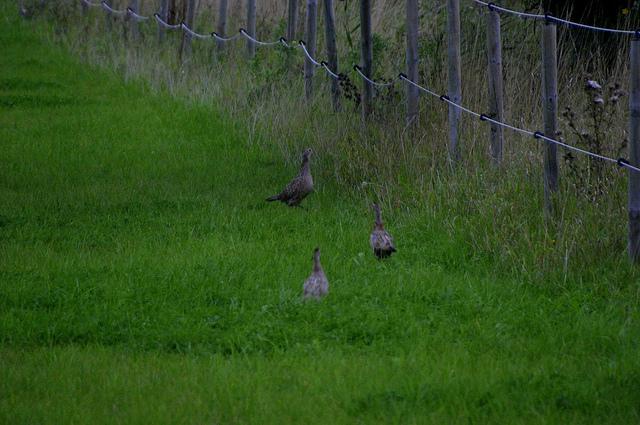Is a fairly steep incline indicated in this photo?
Concise answer only. No. How many animals are in the yard?
Answer briefly. 3. What time of year is it?
Quick response, please. Spring. How many legs does the animal have?
Short answer required. 2. How many poles do you see for the fence?
Concise answer only. 14. What animals are these?
Give a very brief answer. Birds. Are these birds tagged?
Give a very brief answer. No. What kind of animal is standing up?
Give a very brief answer. Bird. How many animals are laying down?
Write a very short answer. 1. Does it look like the scene was shot in winter or summer?
Short answer required. Summer. What colors are the birds?
Short answer required. Gray. Where are the birds?
Quick response, please. In grass. How many animals do you see?
Be succinct. 3. What is covering the ground?
Write a very short answer. Grass. What kind of fence is this?
Quick response, please. Electric. How many brown ducks can you see?
Give a very brief answer. 3. Is the grass patchy?
Quick response, please. No. How many birds are there?
Give a very brief answer. 3. How many birds is there?
Answer briefly. 3. Is this is in the wild?
Quick response, please. No. What color is the fence?
Short answer required. Brown. What kind of animal is this?
Be succinct. Bird. What kind of animals is standing in the grass?
Quick response, please. Ducks. What are the birds doing?
Answer briefly. Walking. What kind of bird is this?
Be succinct. Pigeon. What color is the bird?
Concise answer only. Gray. How many birds?
Keep it brief. 3. Are the birds wild?
Keep it brief. Yes. Is this a friendly park area?
Concise answer only. Yes. Is there snow on the ground?
Be succinct. No. What kind of bird are these?
Write a very short answer. Pigeons. What is the bird standing in front of?
Write a very short answer. Fence. What type of animal is this?
Answer briefly. Bird. Does the grass change color in fall?
Keep it brief. Yes. What type of birds are these?
Write a very short answer. Pigeons. Which animal is this?
Quick response, please. Bird. Are the animals walking around?
Quick response, please. Yes. What type of birds are in this photo?
Write a very short answer. Geese. Is the bird scared of the animal in the foreground?
Short answer required. No. Is this bird in trouble?
Quick response, please. No. Where is barbed wire?
Quick response, please. Fence. How many geese are there?
Give a very brief answer. 3. Are the animals on the same side of the fence?
Keep it brief. Yes. Is the bird looking for food?
Give a very brief answer. Yes. Where is the man standing?
Short answer required. No man. 